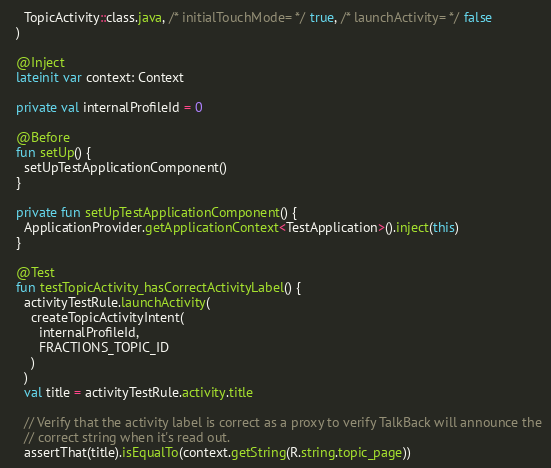Convert code to text. <code><loc_0><loc_0><loc_500><loc_500><_Kotlin_>    TopicActivity::class.java, /* initialTouchMode= */ true, /* launchActivity= */ false
  )

  @Inject
  lateinit var context: Context

  private val internalProfileId = 0

  @Before
  fun setUp() {
    setUpTestApplicationComponent()
  }

  private fun setUpTestApplicationComponent() {
    ApplicationProvider.getApplicationContext<TestApplication>().inject(this)
  }

  @Test
  fun testTopicActivity_hasCorrectActivityLabel() {
    activityTestRule.launchActivity(
      createTopicActivityIntent(
        internalProfileId,
        FRACTIONS_TOPIC_ID
      )
    )
    val title = activityTestRule.activity.title

    // Verify that the activity label is correct as a proxy to verify TalkBack will announce the
    // correct string when it's read out.
    assertThat(title).isEqualTo(context.getString(R.string.topic_page))</code> 